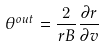<formula> <loc_0><loc_0><loc_500><loc_500>\theta ^ { o u t } = \frac { 2 } { r B } \frac { \partial r } { \partial v }</formula> 